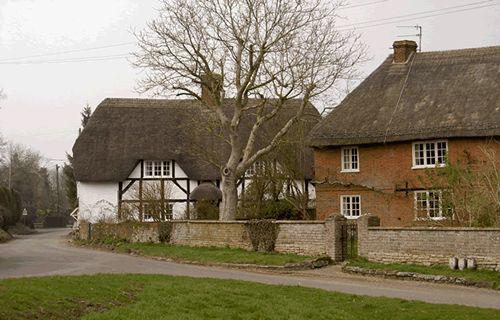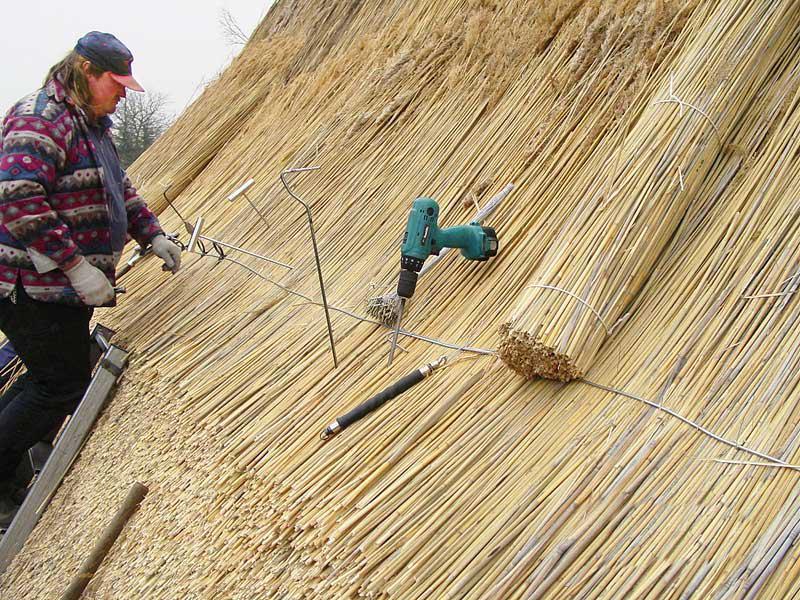The first image is the image on the left, the second image is the image on the right. For the images displayed, is the sentence "Each image shows a building with at least one chimney extending up out of a roof with a sculptural decorative cap over its peaked edge." factually correct? Answer yes or no. No. 